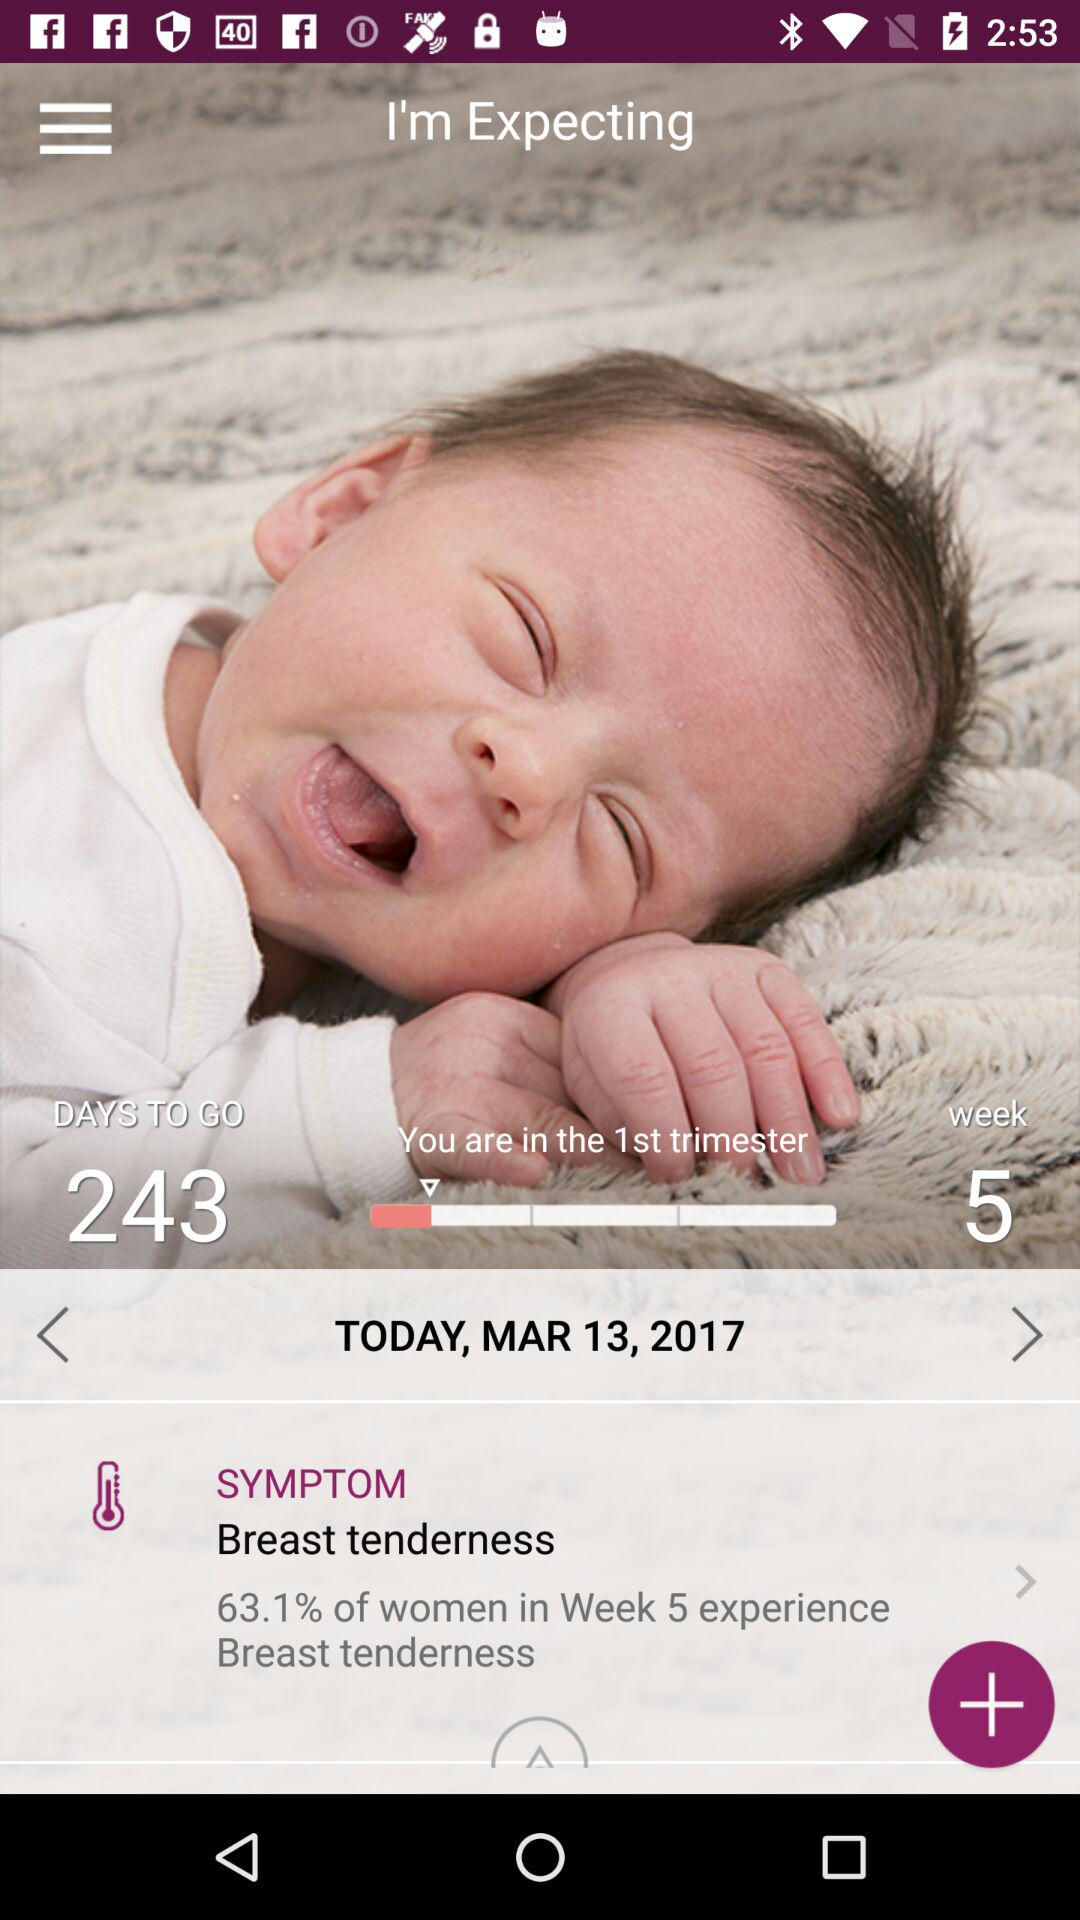What percentage of women experience breast tenderness in week 5?
Answer the question using a single word or phrase. 63.1% 